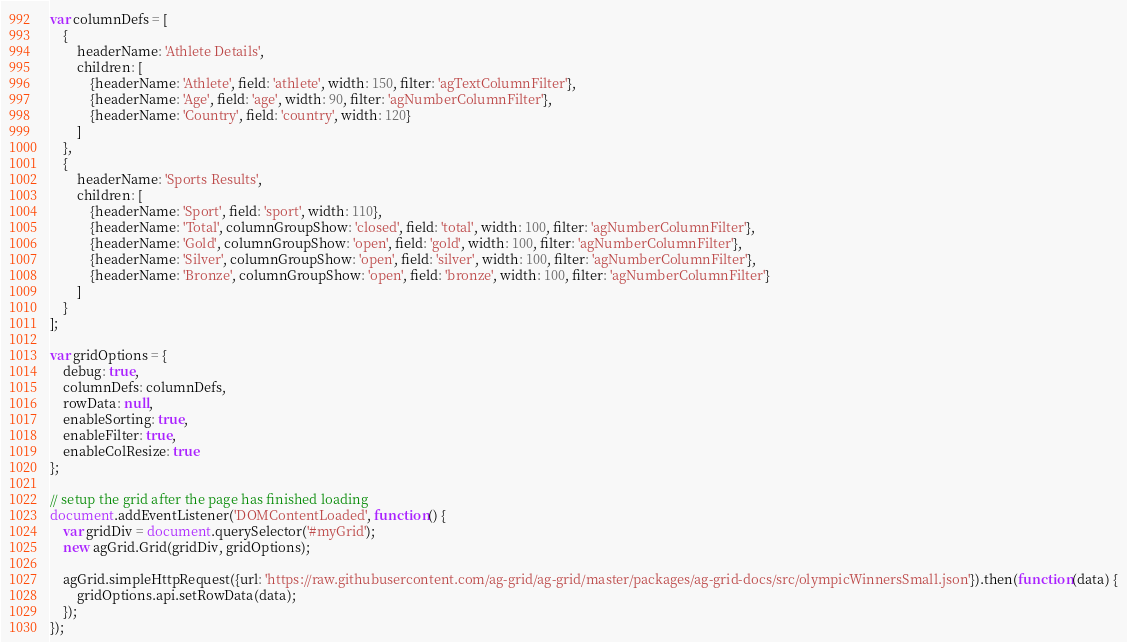Convert code to text. <code><loc_0><loc_0><loc_500><loc_500><_JavaScript_>var columnDefs = [
    {
        headerName: 'Athlete Details',
        children: [
            {headerName: 'Athlete', field: 'athlete', width: 150, filter: 'agTextColumnFilter'},
            {headerName: 'Age', field: 'age', width: 90, filter: 'agNumberColumnFilter'},
            {headerName: 'Country', field: 'country', width: 120}
        ]
    },
    {
        headerName: 'Sports Results',
        children: [
            {headerName: 'Sport', field: 'sport', width: 110},
            {headerName: 'Total', columnGroupShow: 'closed', field: 'total', width: 100, filter: 'agNumberColumnFilter'},
            {headerName: 'Gold', columnGroupShow: 'open', field: 'gold', width: 100, filter: 'agNumberColumnFilter'},
            {headerName: 'Silver', columnGroupShow: 'open', field: 'silver', width: 100, filter: 'agNumberColumnFilter'},
            {headerName: 'Bronze', columnGroupShow: 'open', field: 'bronze', width: 100, filter: 'agNumberColumnFilter'}
        ]
    }
];

var gridOptions = {
    debug: true,
    columnDefs: columnDefs,
    rowData: null,
    enableSorting: true,
    enableFilter: true,
    enableColResize: true
};

// setup the grid after the page has finished loading
document.addEventListener('DOMContentLoaded', function() {
    var gridDiv = document.querySelector('#myGrid');
    new agGrid.Grid(gridDiv, gridOptions);

    agGrid.simpleHttpRequest({url: 'https://raw.githubusercontent.com/ag-grid/ag-grid/master/packages/ag-grid-docs/src/olympicWinnersSmall.json'}).then(function(data) {
        gridOptions.api.setRowData(data);
    });
});</code> 